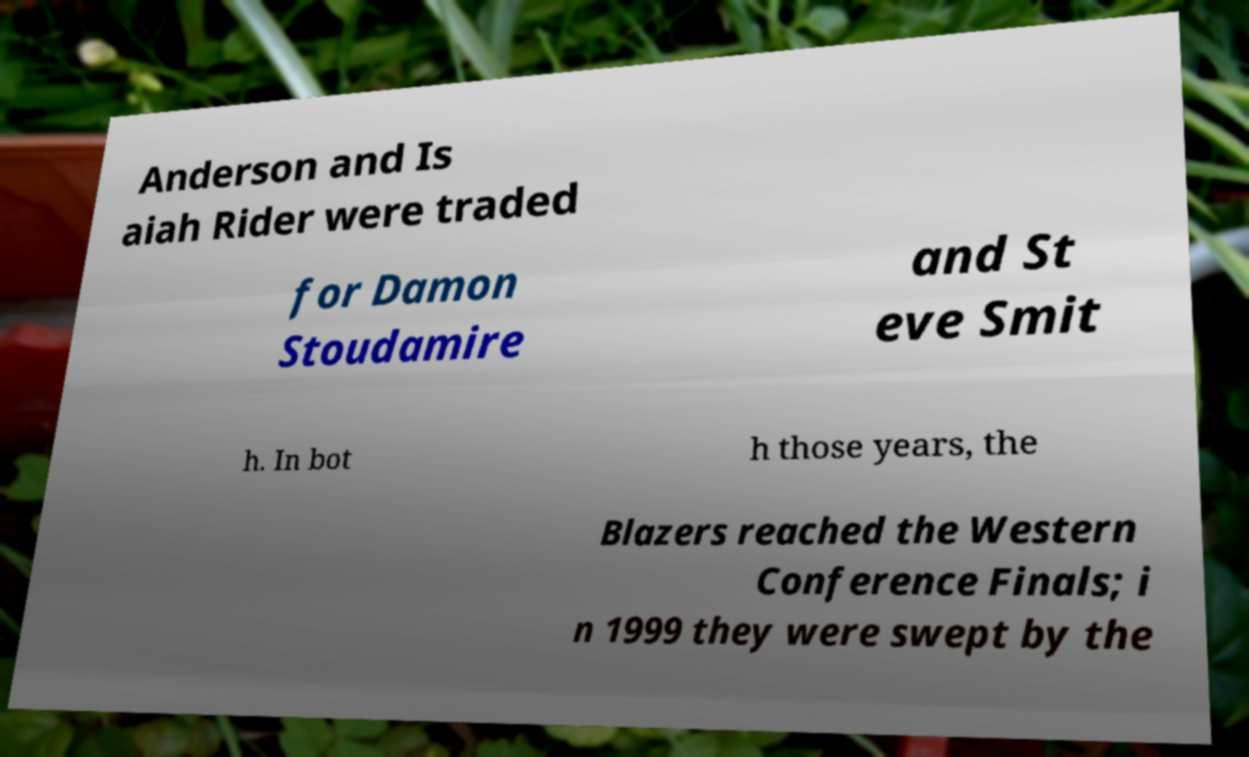For documentation purposes, I need the text within this image transcribed. Could you provide that? Anderson and Is aiah Rider were traded for Damon Stoudamire and St eve Smit h. In bot h those years, the Blazers reached the Western Conference Finals; i n 1999 they were swept by the 